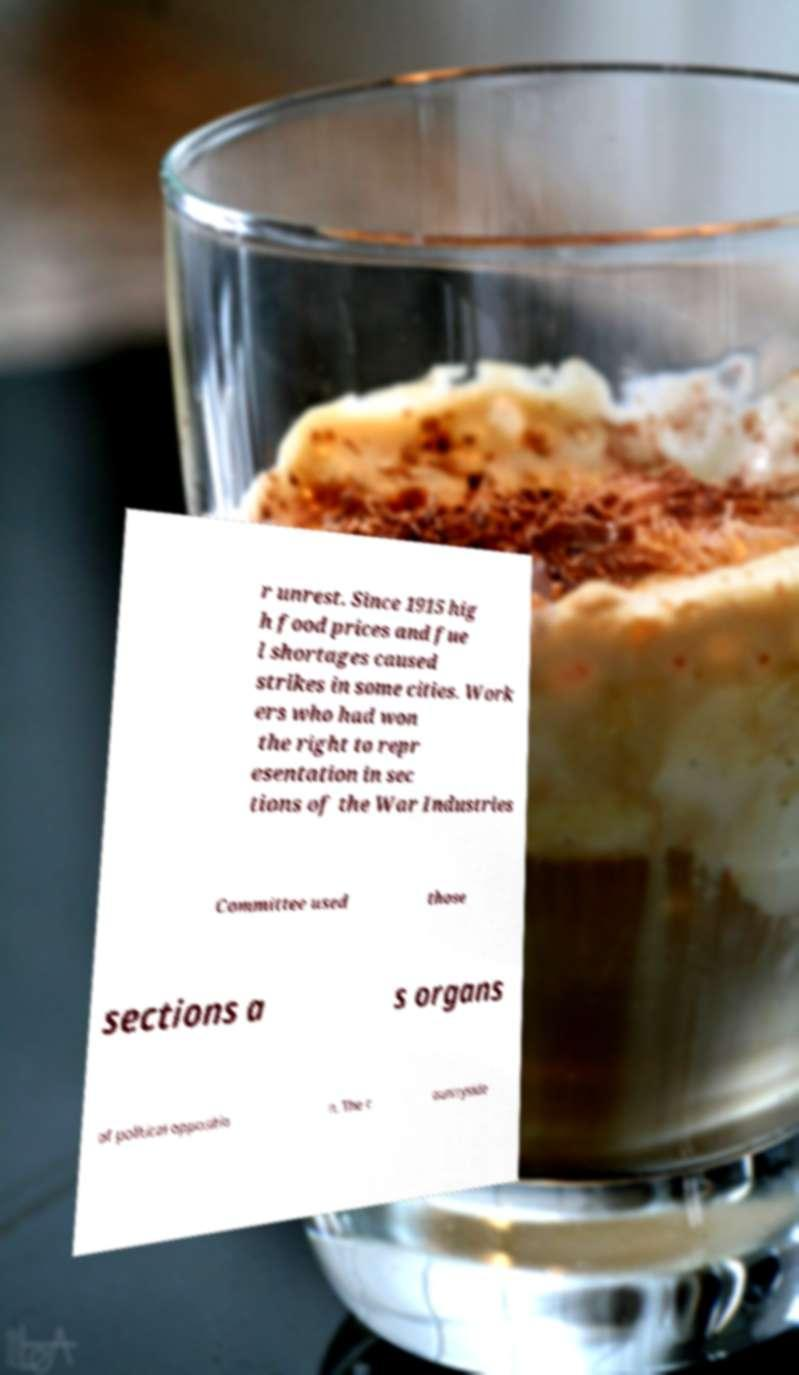For documentation purposes, I need the text within this image transcribed. Could you provide that? r unrest. Since 1915 hig h food prices and fue l shortages caused strikes in some cities. Work ers who had won the right to repr esentation in sec tions of the War Industries Committee used those sections a s organs of political oppositio n. The c ountryside 